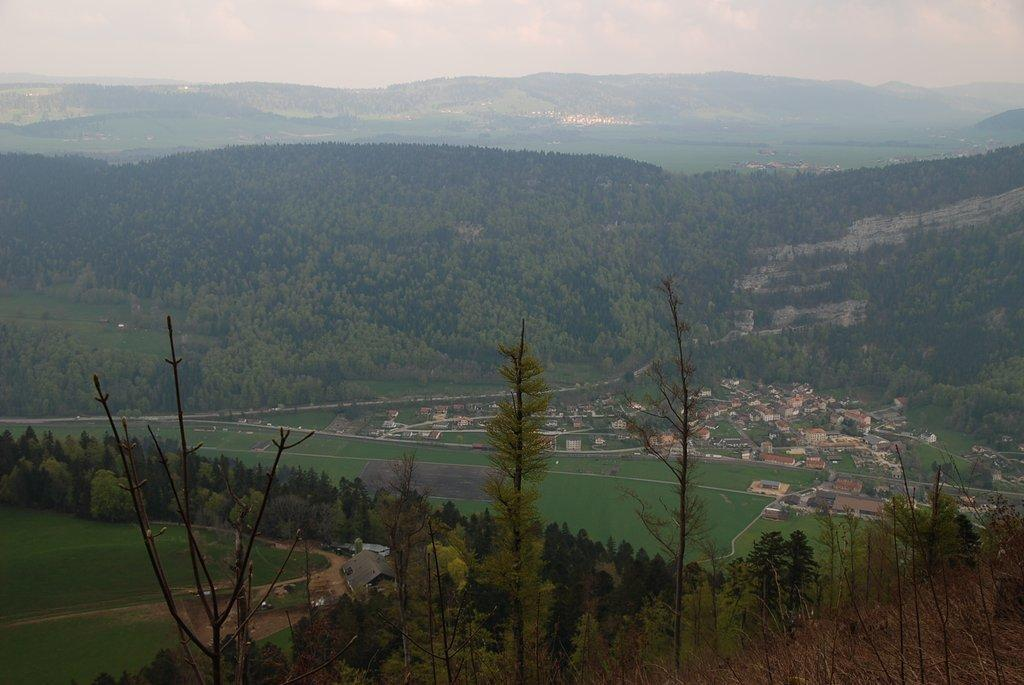What type of surface can be seen in the image? There is a path in the image. What type of vegetation is present in the image? There is grass in the image. What type of natural structures are visible in the image? There are trees and a mountain in the image. What type of man-made structures are visible in the image? There are buildings in the image. What is the condition of the sky in the image? The sky is cloudy in the image. Can you tell me how many times the number 7 is used in the arithmetic equation on the path? There is no arithmetic equation present in the image, so it is not possible to determine how many times the number 7 is used. 